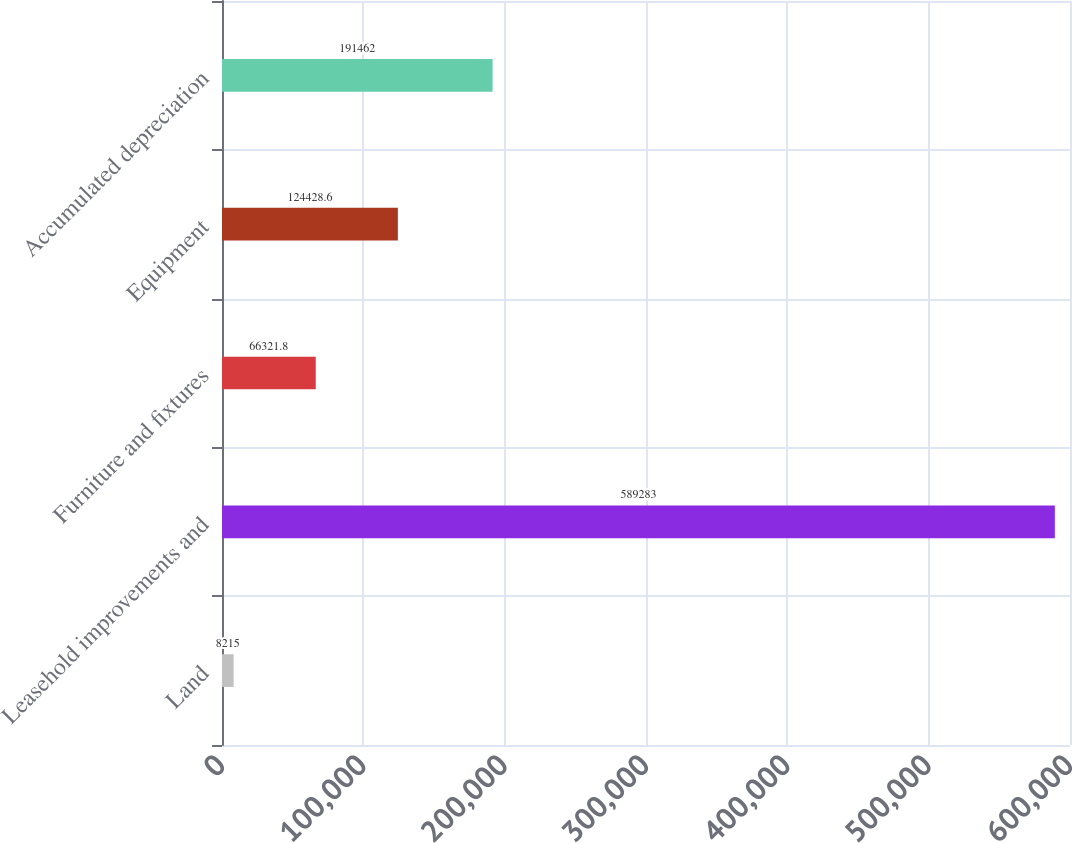<chart> <loc_0><loc_0><loc_500><loc_500><bar_chart><fcel>Land<fcel>Leasehold improvements and<fcel>Furniture and fixtures<fcel>Equipment<fcel>Accumulated depreciation<nl><fcel>8215<fcel>589283<fcel>66321.8<fcel>124429<fcel>191462<nl></chart> 